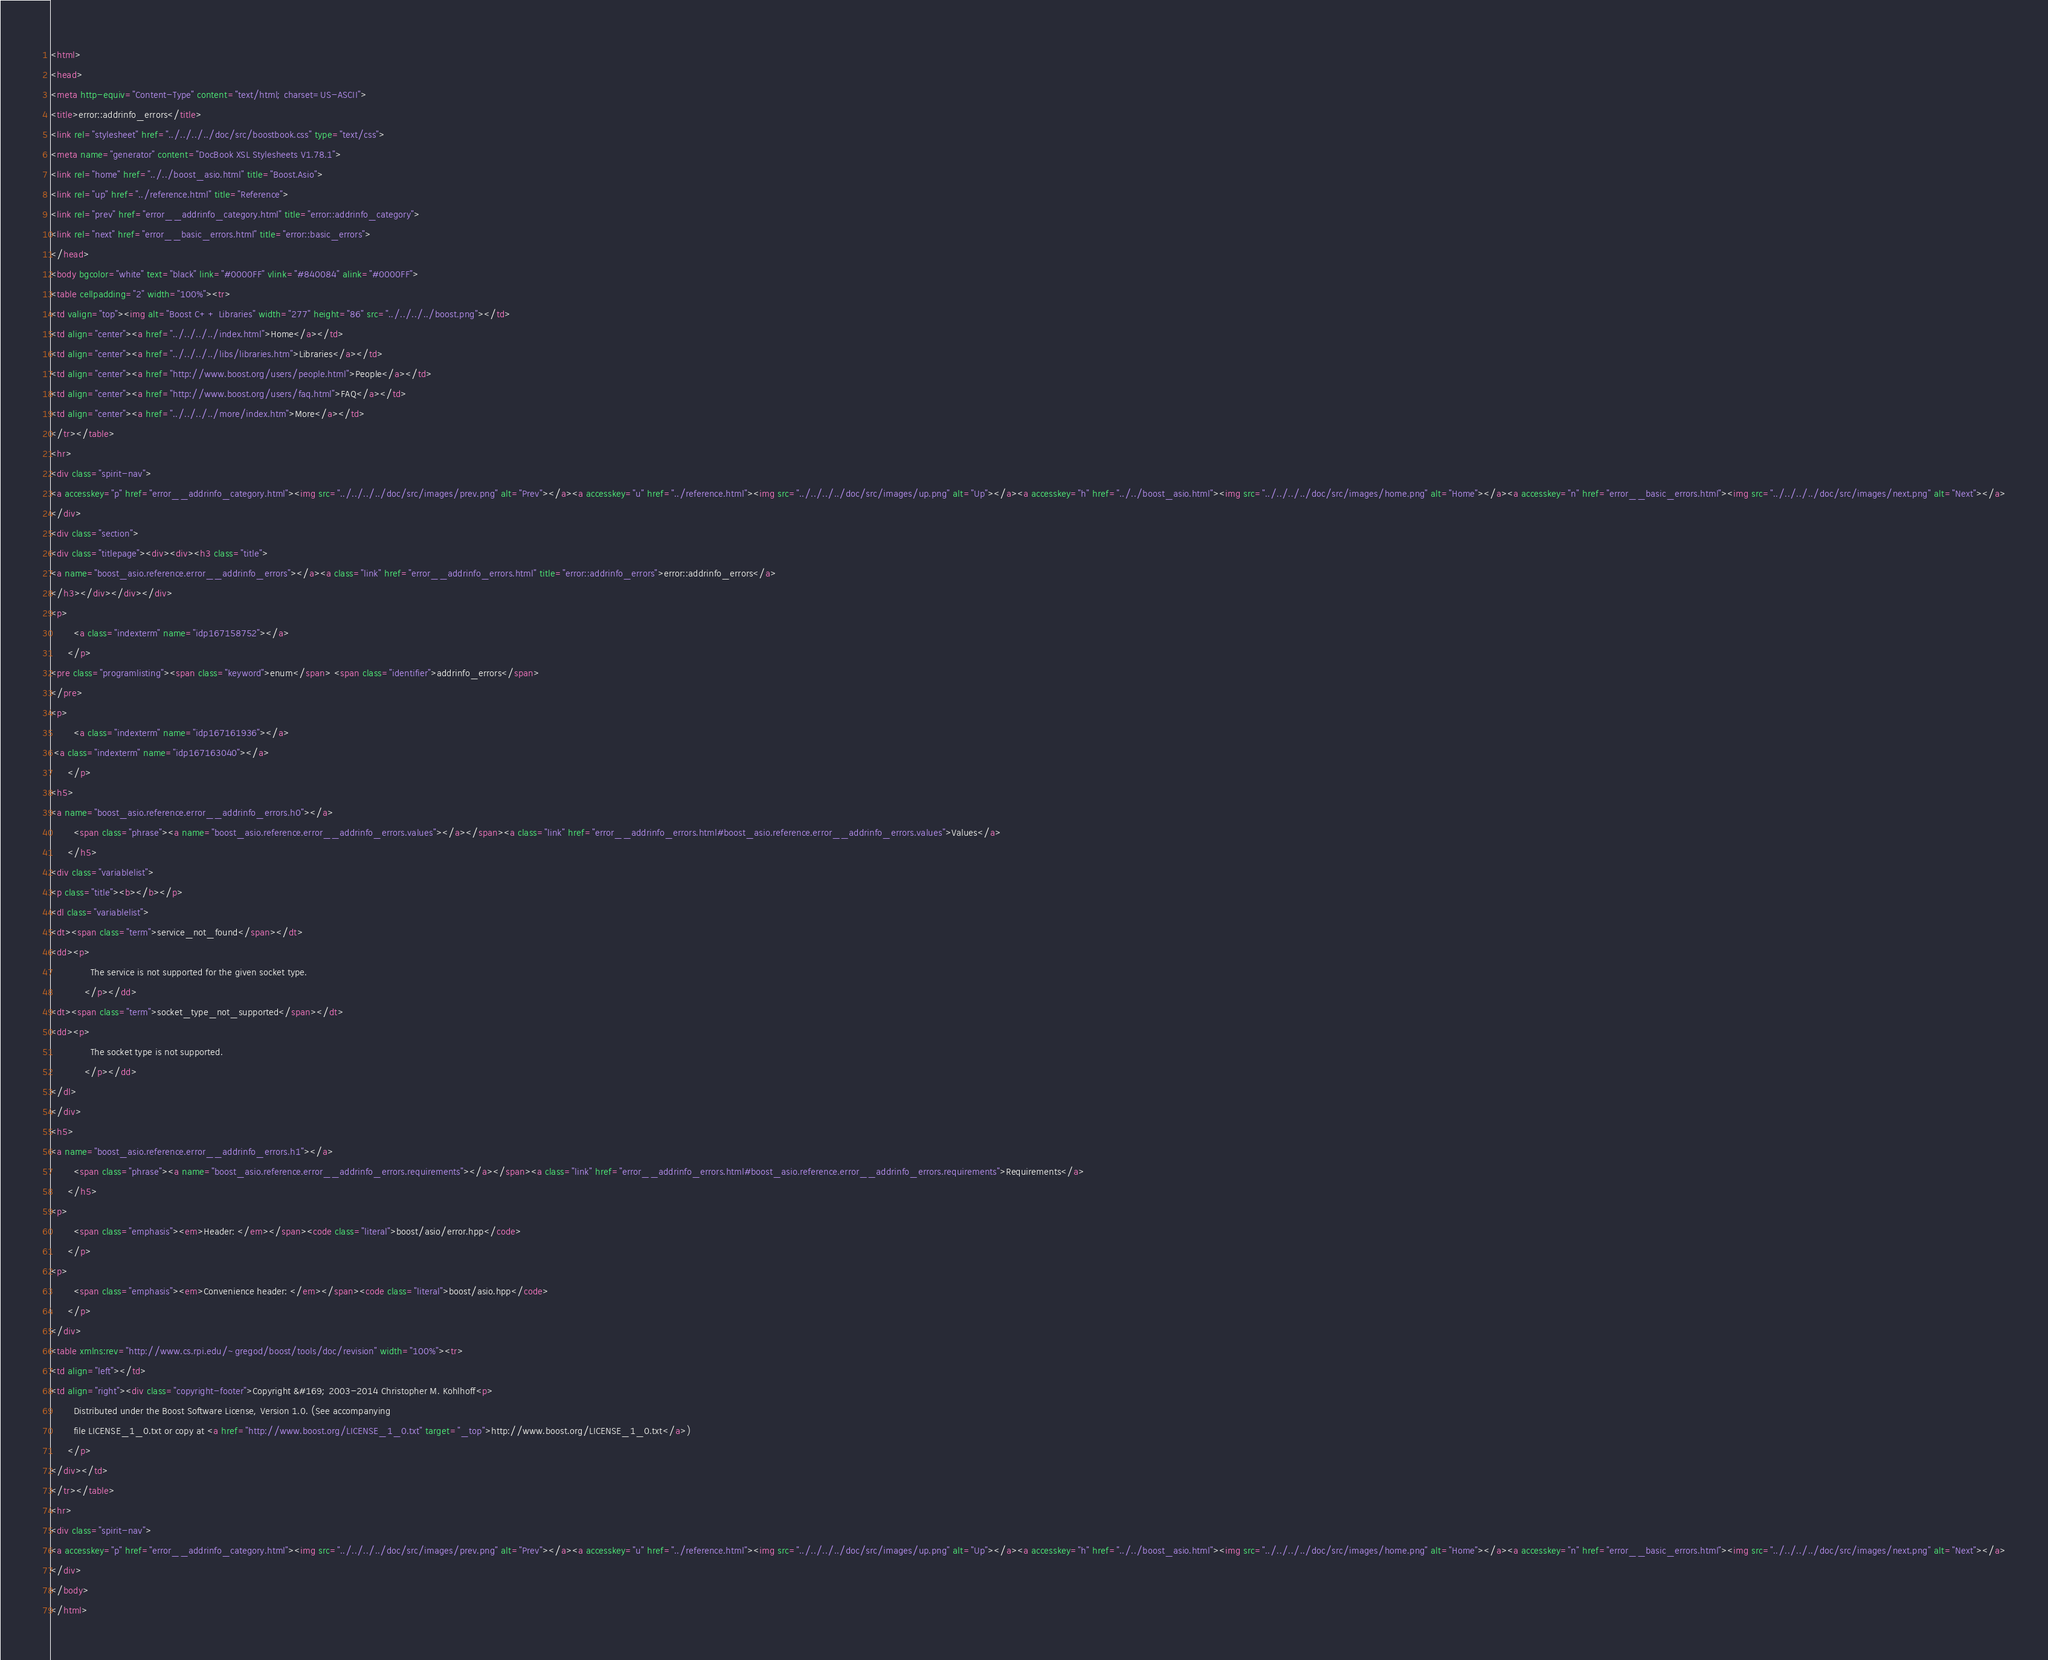Convert code to text. <code><loc_0><loc_0><loc_500><loc_500><_HTML_><html>
<head>
<meta http-equiv="Content-Type" content="text/html; charset=US-ASCII">
<title>error::addrinfo_errors</title>
<link rel="stylesheet" href="../../../../doc/src/boostbook.css" type="text/css">
<meta name="generator" content="DocBook XSL Stylesheets V1.78.1">
<link rel="home" href="../../boost_asio.html" title="Boost.Asio">
<link rel="up" href="../reference.html" title="Reference">
<link rel="prev" href="error__addrinfo_category.html" title="error::addrinfo_category">
<link rel="next" href="error__basic_errors.html" title="error::basic_errors">
</head>
<body bgcolor="white" text="black" link="#0000FF" vlink="#840084" alink="#0000FF">
<table cellpadding="2" width="100%"><tr>
<td valign="top"><img alt="Boost C++ Libraries" width="277" height="86" src="../../../../boost.png"></td>
<td align="center"><a href="../../../../index.html">Home</a></td>
<td align="center"><a href="../../../../libs/libraries.htm">Libraries</a></td>
<td align="center"><a href="http://www.boost.org/users/people.html">People</a></td>
<td align="center"><a href="http://www.boost.org/users/faq.html">FAQ</a></td>
<td align="center"><a href="../../../../more/index.htm">More</a></td>
</tr></table>
<hr>
<div class="spirit-nav">
<a accesskey="p" href="error__addrinfo_category.html"><img src="../../../../doc/src/images/prev.png" alt="Prev"></a><a accesskey="u" href="../reference.html"><img src="../../../../doc/src/images/up.png" alt="Up"></a><a accesskey="h" href="../../boost_asio.html"><img src="../../../../doc/src/images/home.png" alt="Home"></a><a accesskey="n" href="error__basic_errors.html"><img src="../../../../doc/src/images/next.png" alt="Next"></a>
</div>
<div class="section">
<div class="titlepage"><div><div><h3 class="title">
<a name="boost_asio.reference.error__addrinfo_errors"></a><a class="link" href="error__addrinfo_errors.html" title="error::addrinfo_errors">error::addrinfo_errors</a>
</h3></div></div></div>
<p>
        <a class="indexterm" name="idp167158752"></a>
      </p>
<pre class="programlisting"><span class="keyword">enum</span> <span class="identifier">addrinfo_errors</span>
</pre>
<p>
        <a class="indexterm" name="idp167161936"></a>
 <a class="indexterm" name="idp167163040"></a>
      </p>
<h5>
<a name="boost_asio.reference.error__addrinfo_errors.h0"></a>
        <span class="phrase"><a name="boost_asio.reference.error__addrinfo_errors.values"></a></span><a class="link" href="error__addrinfo_errors.html#boost_asio.reference.error__addrinfo_errors.values">Values</a>
      </h5>
<div class="variablelist">
<p class="title"><b></b></p>
<dl class="variablelist">
<dt><span class="term">service_not_found</span></dt>
<dd><p>
              The service is not supported for the given socket type.
            </p></dd>
<dt><span class="term">socket_type_not_supported</span></dt>
<dd><p>
              The socket type is not supported.
            </p></dd>
</dl>
</div>
<h5>
<a name="boost_asio.reference.error__addrinfo_errors.h1"></a>
        <span class="phrase"><a name="boost_asio.reference.error__addrinfo_errors.requirements"></a></span><a class="link" href="error__addrinfo_errors.html#boost_asio.reference.error__addrinfo_errors.requirements">Requirements</a>
      </h5>
<p>
        <span class="emphasis"><em>Header: </em></span><code class="literal">boost/asio/error.hpp</code>
      </p>
<p>
        <span class="emphasis"><em>Convenience header: </em></span><code class="literal">boost/asio.hpp</code>
      </p>
</div>
<table xmlns:rev="http://www.cs.rpi.edu/~gregod/boost/tools/doc/revision" width="100%"><tr>
<td align="left"></td>
<td align="right"><div class="copyright-footer">Copyright &#169; 2003-2014 Christopher M. Kohlhoff<p>
        Distributed under the Boost Software License, Version 1.0. (See accompanying
        file LICENSE_1_0.txt or copy at <a href="http://www.boost.org/LICENSE_1_0.txt" target="_top">http://www.boost.org/LICENSE_1_0.txt</a>)
      </p>
</div></td>
</tr></table>
<hr>
<div class="spirit-nav">
<a accesskey="p" href="error__addrinfo_category.html"><img src="../../../../doc/src/images/prev.png" alt="Prev"></a><a accesskey="u" href="../reference.html"><img src="../../../../doc/src/images/up.png" alt="Up"></a><a accesskey="h" href="../../boost_asio.html"><img src="../../../../doc/src/images/home.png" alt="Home"></a><a accesskey="n" href="error__basic_errors.html"><img src="../../../../doc/src/images/next.png" alt="Next"></a>
</div>
</body>
</html>
</code> 